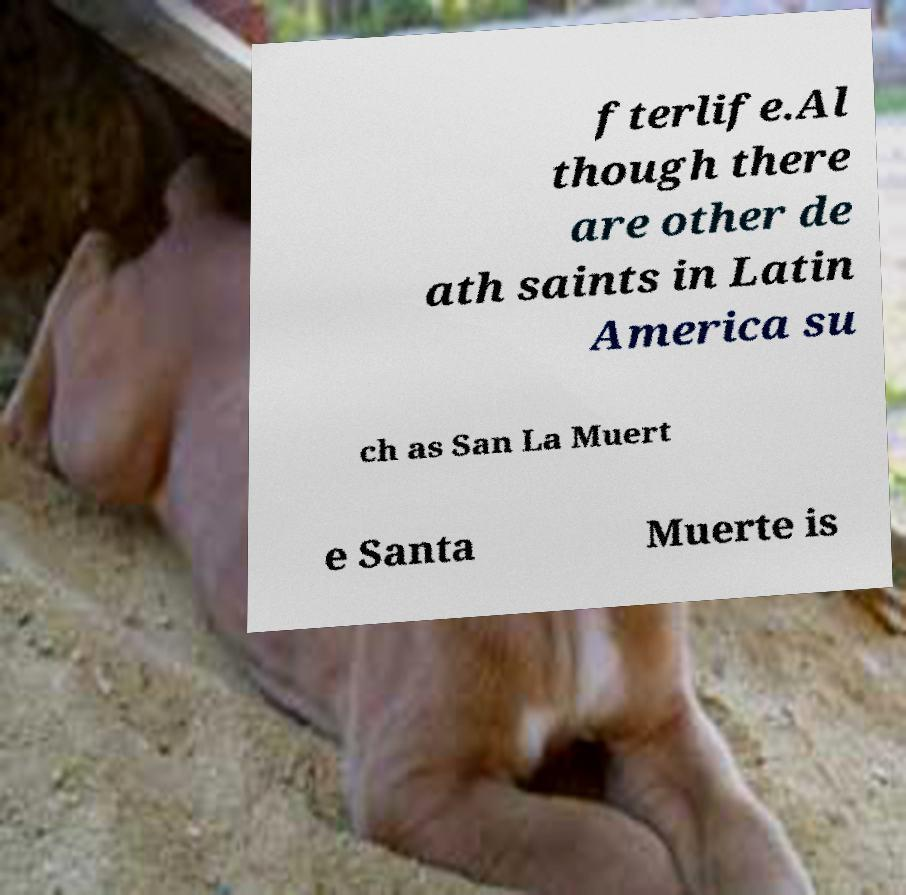Can you accurately transcribe the text from the provided image for me? fterlife.Al though there are other de ath saints in Latin America su ch as San La Muert e Santa Muerte is 